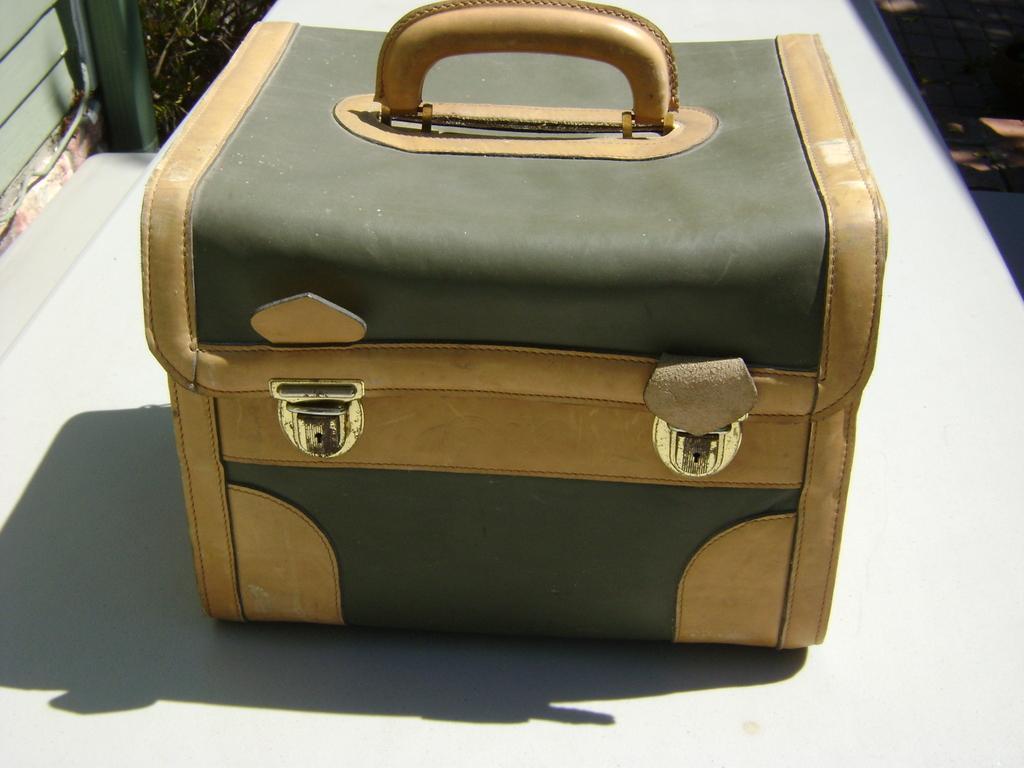Can you describe this image briefly? In this picture there is a bag with two clips placed on the floor. There is a handle. The floor is in white color. 